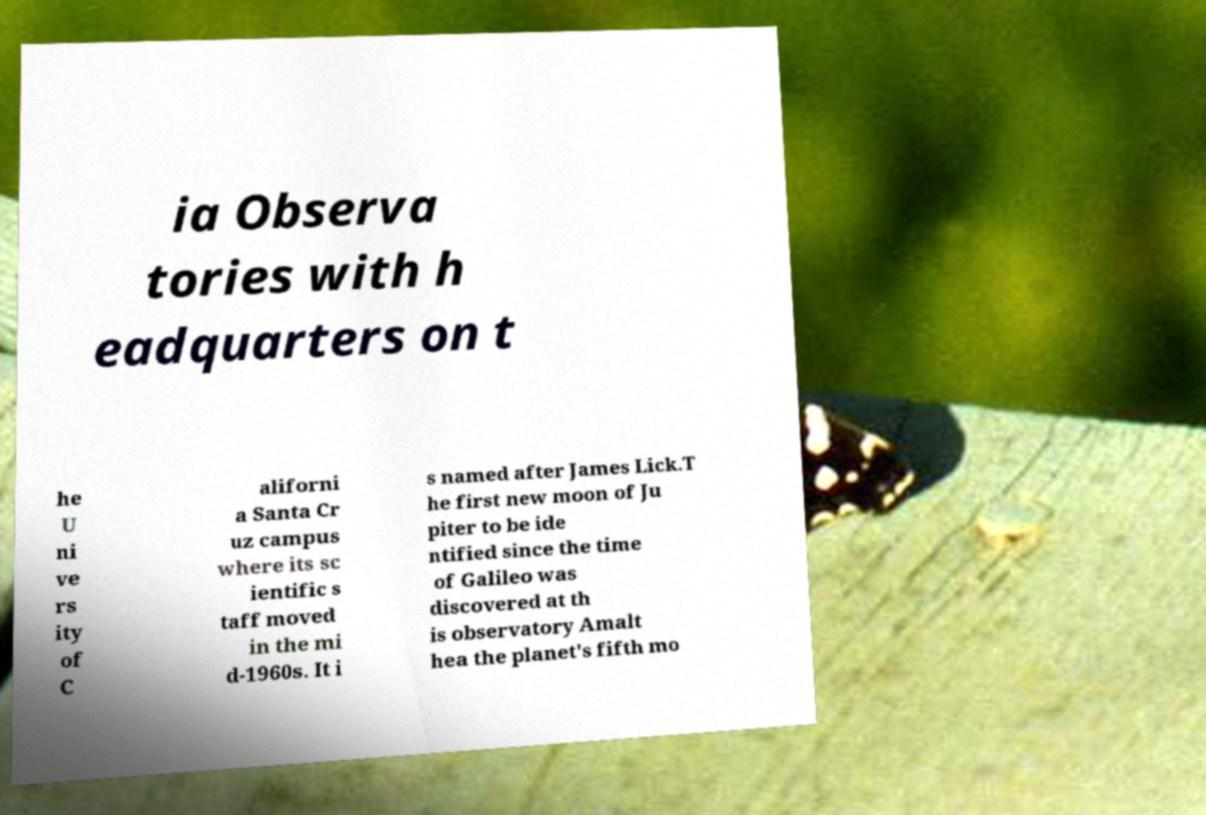Could you extract and type out the text from this image? ia Observa tories with h eadquarters on t he U ni ve rs ity of C aliforni a Santa Cr uz campus where its sc ientific s taff moved in the mi d-1960s. It i s named after James Lick.T he first new moon of Ju piter to be ide ntified since the time of Galileo was discovered at th is observatory Amalt hea the planet's fifth mo 